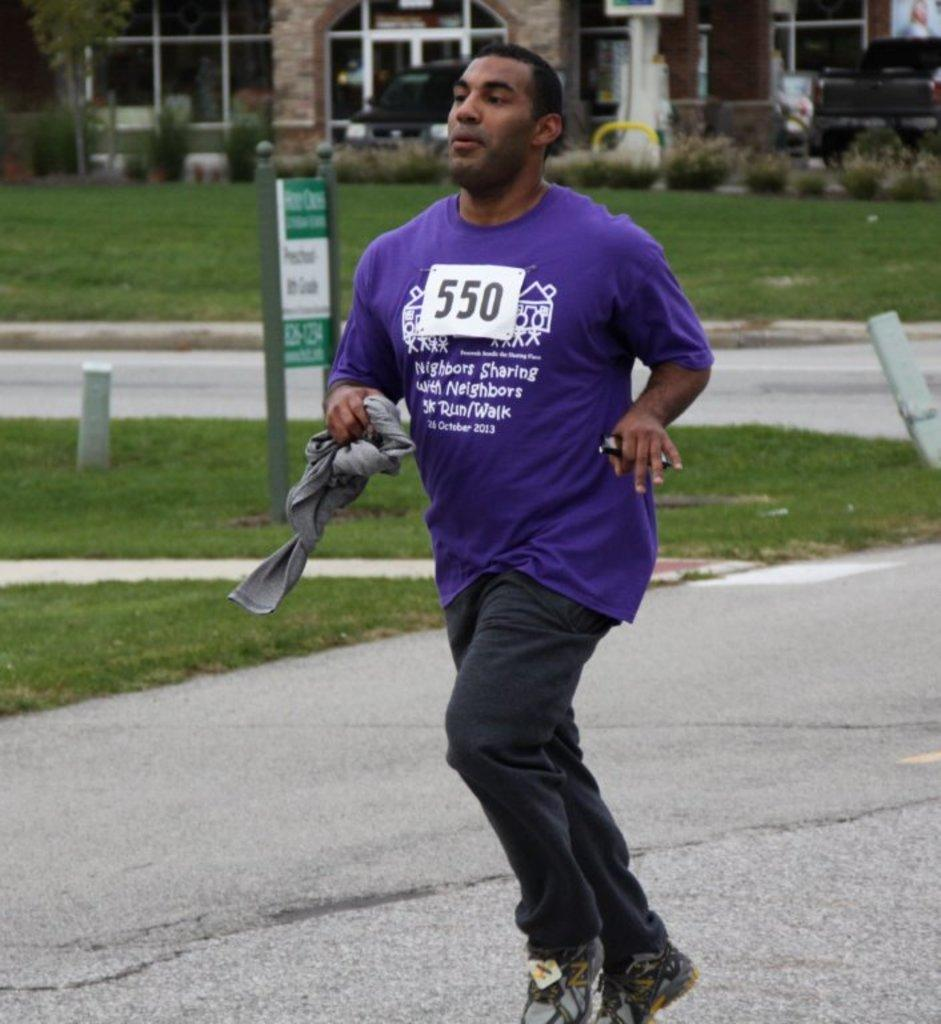What is the person in the image doing? The person is running in the image. Where is the person running? The person is running on a road. What type of vegetation can be seen in the image? There is grass visible in the image. What else can be seen in the image besides the person running? There is a sign board and a building in the image. What type of crime is being committed in the image? There is no indication of any crime being committed in the image. The person is simply running on a road. 